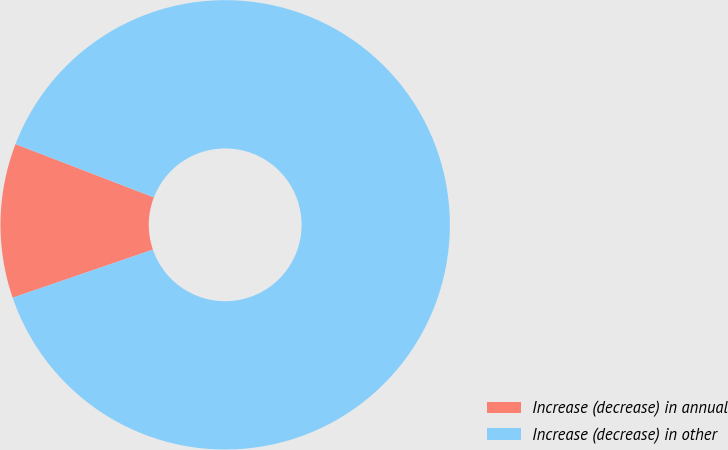<chart> <loc_0><loc_0><loc_500><loc_500><pie_chart><fcel>Increase (decrease) in annual<fcel>Increase (decrease) in other<nl><fcel>11.11%<fcel>88.89%<nl></chart> 